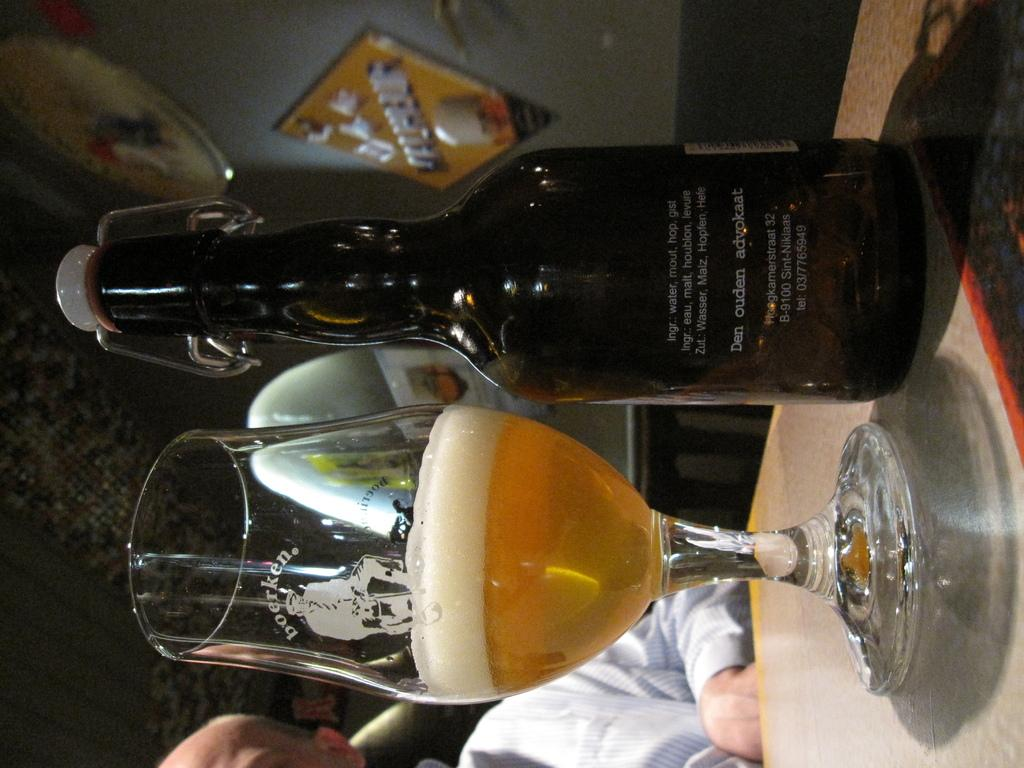What objects are on the table in the image? There is a bottle and a glass on the table in the image. Who is present in the image? There is a man in the image. Can you describe the man's position in relation to the table? The man is not visible in relation to the table, as the facts only mention his presence in the image. What type of fork is the man using to stir the contents of the pail in the image? There is no fork, man, or pail present in the image. 